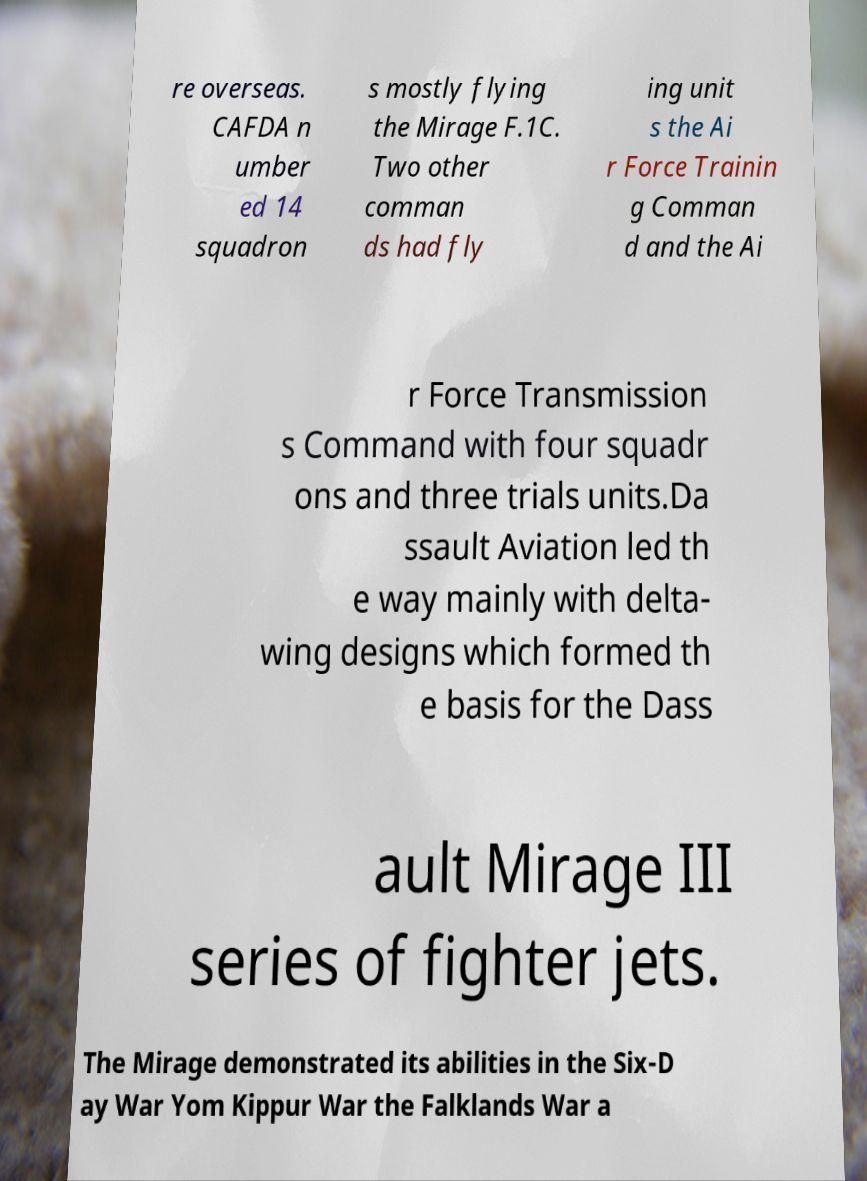Please identify and transcribe the text found in this image. re overseas. CAFDA n umber ed 14 squadron s mostly flying the Mirage F.1C. Two other comman ds had fly ing unit s the Ai r Force Trainin g Comman d and the Ai r Force Transmission s Command with four squadr ons and three trials units.Da ssault Aviation led th e way mainly with delta- wing designs which formed th e basis for the Dass ault Mirage III series of fighter jets. The Mirage demonstrated its abilities in the Six-D ay War Yom Kippur War the Falklands War a 